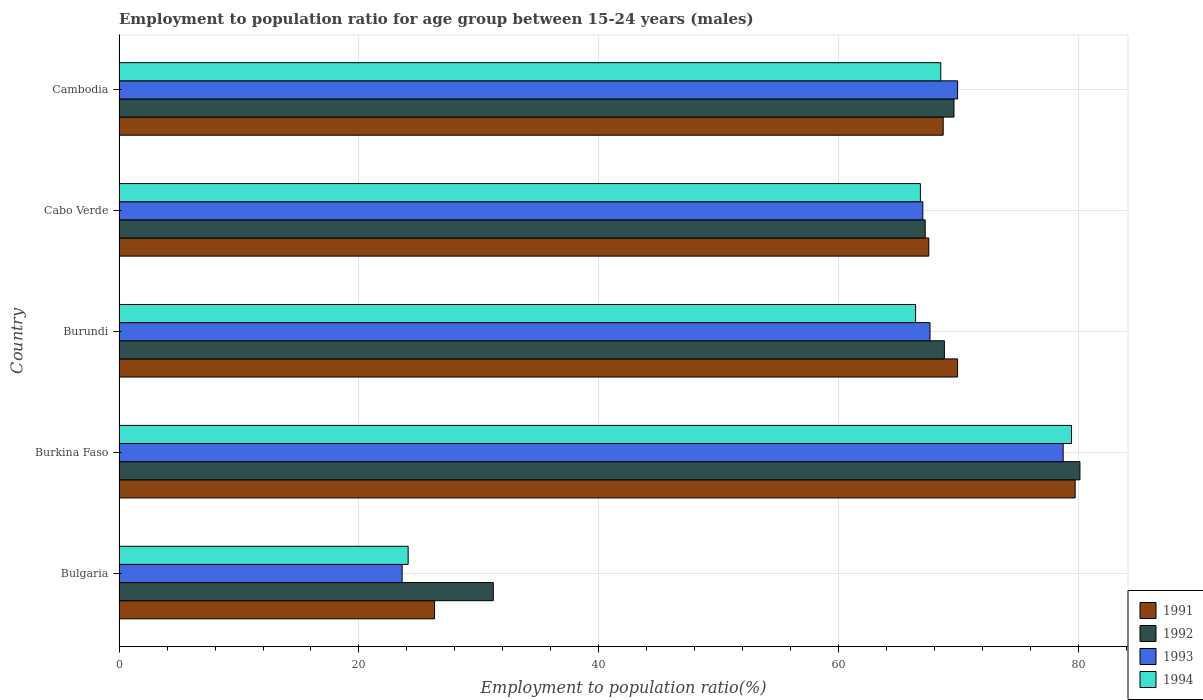How many different coloured bars are there?
Offer a terse response. 4. How many groups of bars are there?
Provide a succinct answer. 5. Are the number of bars on each tick of the Y-axis equal?
Provide a succinct answer. Yes. How many bars are there on the 4th tick from the top?
Keep it short and to the point. 4. How many bars are there on the 1st tick from the bottom?
Offer a terse response. 4. What is the label of the 3rd group of bars from the top?
Keep it short and to the point. Burundi. What is the employment to population ratio in 1992 in Burkina Faso?
Your answer should be compact. 80.1. Across all countries, what is the maximum employment to population ratio in 1993?
Offer a very short reply. 78.7. Across all countries, what is the minimum employment to population ratio in 1993?
Keep it short and to the point. 23.6. In which country was the employment to population ratio in 1994 maximum?
Provide a short and direct response. Burkina Faso. What is the total employment to population ratio in 1992 in the graph?
Provide a short and direct response. 316.9. What is the difference between the employment to population ratio in 1993 in Bulgaria and that in Burundi?
Provide a succinct answer. -44. What is the difference between the employment to population ratio in 1994 in Cambodia and the employment to population ratio in 1991 in Bulgaria?
Offer a very short reply. 42.2. What is the average employment to population ratio in 1991 per country?
Provide a succinct answer. 62.42. What is the difference between the employment to population ratio in 1993 and employment to population ratio in 1994 in Bulgaria?
Keep it short and to the point. -0.5. What is the ratio of the employment to population ratio in 1991 in Bulgaria to that in Burkina Faso?
Keep it short and to the point. 0.33. Is the employment to population ratio in 1991 in Bulgaria less than that in Burundi?
Make the answer very short. Yes. Is the difference between the employment to population ratio in 1993 in Burkina Faso and Cambodia greater than the difference between the employment to population ratio in 1994 in Burkina Faso and Cambodia?
Ensure brevity in your answer.  No. What is the difference between the highest and the lowest employment to population ratio in 1992?
Give a very brief answer. 48.9. Is it the case that in every country, the sum of the employment to population ratio in 1994 and employment to population ratio in 1991 is greater than the sum of employment to population ratio in 1993 and employment to population ratio in 1992?
Offer a terse response. No. Is it the case that in every country, the sum of the employment to population ratio in 1993 and employment to population ratio in 1992 is greater than the employment to population ratio in 1991?
Offer a terse response. Yes. How many bars are there?
Ensure brevity in your answer.  20. Are all the bars in the graph horizontal?
Give a very brief answer. Yes. How many countries are there in the graph?
Offer a very short reply. 5. What is the difference between two consecutive major ticks on the X-axis?
Give a very brief answer. 20. Are the values on the major ticks of X-axis written in scientific E-notation?
Make the answer very short. No. Does the graph contain any zero values?
Offer a terse response. No. Does the graph contain grids?
Keep it short and to the point. Yes. Where does the legend appear in the graph?
Your answer should be very brief. Bottom right. How are the legend labels stacked?
Make the answer very short. Vertical. What is the title of the graph?
Your answer should be very brief. Employment to population ratio for age group between 15-24 years (males). What is the label or title of the Y-axis?
Make the answer very short. Country. What is the Employment to population ratio(%) of 1991 in Bulgaria?
Offer a terse response. 26.3. What is the Employment to population ratio(%) of 1992 in Bulgaria?
Ensure brevity in your answer.  31.2. What is the Employment to population ratio(%) in 1993 in Bulgaria?
Keep it short and to the point. 23.6. What is the Employment to population ratio(%) in 1994 in Bulgaria?
Offer a terse response. 24.1. What is the Employment to population ratio(%) of 1991 in Burkina Faso?
Your answer should be compact. 79.7. What is the Employment to population ratio(%) of 1992 in Burkina Faso?
Your answer should be very brief. 80.1. What is the Employment to population ratio(%) in 1993 in Burkina Faso?
Give a very brief answer. 78.7. What is the Employment to population ratio(%) of 1994 in Burkina Faso?
Provide a short and direct response. 79.4. What is the Employment to population ratio(%) in 1991 in Burundi?
Provide a short and direct response. 69.9. What is the Employment to population ratio(%) of 1992 in Burundi?
Your response must be concise. 68.8. What is the Employment to population ratio(%) in 1993 in Burundi?
Make the answer very short. 67.6. What is the Employment to population ratio(%) of 1994 in Burundi?
Give a very brief answer. 66.4. What is the Employment to population ratio(%) in 1991 in Cabo Verde?
Your answer should be very brief. 67.5. What is the Employment to population ratio(%) in 1992 in Cabo Verde?
Keep it short and to the point. 67.2. What is the Employment to population ratio(%) in 1994 in Cabo Verde?
Give a very brief answer. 66.8. What is the Employment to population ratio(%) in 1991 in Cambodia?
Keep it short and to the point. 68.7. What is the Employment to population ratio(%) of 1992 in Cambodia?
Offer a very short reply. 69.6. What is the Employment to population ratio(%) in 1993 in Cambodia?
Provide a succinct answer. 69.9. What is the Employment to population ratio(%) in 1994 in Cambodia?
Provide a short and direct response. 68.5. Across all countries, what is the maximum Employment to population ratio(%) in 1991?
Make the answer very short. 79.7. Across all countries, what is the maximum Employment to population ratio(%) in 1992?
Offer a very short reply. 80.1. Across all countries, what is the maximum Employment to population ratio(%) in 1993?
Offer a very short reply. 78.7. Across all countries, what is the maximum Employment to population ratio(%) in 1994?
Make the answer very short. 79.4. Across all countries, what is the minimum Employment to population ratio(%) of 1991?
Your answer should be very brief. 26.3. Across all countries, what is the minimum Employment to population ratio(%) in 1992?
Your answer should be very brief. 31.2. Across all countries, what is the minimum Employment to population ratio(%) in 1993?
Ensure brevity in your answer.  23.6. Across all countries, what is the minimum Employment to population ratio(%) of 1994?
Offer a very short reply. 24.1. What is the total Employment to population ratio(%) in 1991 in the graph?
Offer a very short reply. 312.1. What is the total Employment to population ratio(%) of 1992 in the graph?
Your answer should be very brief. 316.9. What is the total Employment to population ratio(%) of 1993 in the graph?
Offer a terse response. 306.8. What is the total Employment to population ratio(%) of 1994 in the graph?
Provide a succinct answer. 305.2. What is the difference between the Employment to population ratio(%) in 1991 in Bulgaria and that in Burkina Faso?
Your answer should be compact. -53.4. What is the difference between the Employment to population ratio(%) of 1992 in Bulgaria and that in Burkina Faso?
Provide a succinct answer. -48.9. What is the difference between the Employment to population ratio(%) in 1993 in Bulgaria and that in Burkina Faso?
Provide a short and direct response. -55.1. What is the difference between the Employment to population ratio(%) of 1994 in Bulgaria and that in Burkina Faso?
Offer a terse response. -55.3. What is the difference between the Employment to population ratio(%) of 1991 in Bulgaria and that in Burundi?
Ensure brevity in your answer.  -43.6. What is the difference between the Employment to population ratio(%) of 1992 in Bulgaria and that in Burundi?
Provide a short and direct response. -37.6. What is the difference between the Employment to population ratio(%) of 1993 in Bulgaria and that in Burundi?
Offer a terse response. -44. What is the difference between the Employment to population ratio(%) of 1994 in Bulgaria and that in Burundi?
Provide a succinct answer. -42.3. What is the difference between the Employment to population ratio(%) of 1991 in Bulgaria and that in Cabo Verde?
Offer a very short reply. -41.2. What is the difference between the Employment to population ratio(%) of 1992 in Bulgaria and that in Cabo Verde?
Provide a succinct answer. -36. What is the difference between the Employment to population ratio(%) of 1993 in Bulgaria and that in Cabo Verde?
Provide a short and direct response. -43.4. What is the difference between the Employment to population ratio(%) of 1994 in Bulgaria and that in Cabo Verde?
Offer a terse response. -42.7. What is the difference between the Employment to population ratio(%) in 1991 in Bulgaria and that in Cambodia?
Offer a terse response. -42.4. What is the difference between the Employment to population ratio(%) of 1992 in Bulgaria and that in Cambodia?
Provide a succinct answer. -38.4. What is the difference between the Employment to population ratio(%) of 1993 in Bulgaria and that in Cambodia?
Offer a very short reply. -46.3. What is the difference between the Employment to population ratio(%) of 1994 in Bulgaria and that in Cambodia?
Provide a succinct answer. -44.4. What is the difference between the Employment to population ratio(%) in 1991 in Burkina Faso and that in Burundi?
Your answer should be compact. 9.8. What is the difference between the Employment to population ratio(%) in 1993 in Burkina Faso and that in Burundi?
Offer a terse response. 11.1. What is the difference between the Employment to population ratio(%) of 1994 in Burkina Faso and that in Burundi?
Your response must be concise. 13. What is the difference between the Employment to population ratio(%) in 1992 in Burkina Faso and that in Cabo Verde?
Your answer should be very brief. 12.9. What is the difference between the Employment to population ratio(%) in 1993 in Burkina Faso and that in Cabo Verde?
Your answer should be very brief. 11.7. What is the difference between the Employment to population ratio(%) in 1992 in Burkina Faso and that in Cambodia?
Ensure brevity in your answer.  10.5. What is the difference between the Employment to population ratio(%) in 1994 in Burkina Faso and that in Cambodia?
Keep it short and to the point. 10.9. What is the difference between the Employment to population ratio(%) in 1991 in Burundi and that in Cabo Verde?
Your answer should be very brief. 2.4. What is the difference between the Employment to population ratio(%) of 1992 in Burundi and that in Cabo Verde?
Give a very brief answer. 1.6. What is the difference between the Employment to population ratio(%) of 1993 in Burundi and that in Cabo Verde?
Provide a succinct answer. 0.6. What is the difference between the Employment to population ratio(%) in 1994 in Burundi and that in Cabo Verde?
Offer a terse response. -0.4. What is the difference between the Employment to population ratio(%) of 1991 in Burundi and that in Cambodia?
Keep it short and to the point. 1.2. What is the difference between the Employment to population ratio(%) in 1994 in Burundi and that in Cambodia?
Your response must be concise. -2.1. What is the difference between the Employment to population ratio(%) of 1991 in Cabo Verde and that in Cambodia?
Provide a succinct answer. -1.2. What is the difference between the Employment to population ratio(%) of 1991 in Bulgaria and the Employment to population ratio(%) of 1992 in Burkina Faso?
Make the answer very short. -53.8. What is the difference between the Employment to population ratio(%) of 1991 in Bulgaria and the Employment to population ratio(%) of 1993 in Burkina Faso?
Keep it short and to the point. -52.4. What is the difference between the Employment to population ratio(%) in 1991 in Bulgaria and the Employment to population ratio(%) in 1994 in Burkina Faso?
Provide a short and direct response. -53.1. What is the difference between the Employment to population ratio(%) of 1992 in Bulgaria and the Employment to population ratio(%) of 1993 in Burkina Faso?
Give a very brief answer. -47.5. What is the difference between the Employment to population ratio(%) in 1992 in Bulgaria and the Employment to population ratio(%) in 1994 in Burkina Faso?
Ensure brevity in your answer.  -48.2. What is the difference between the Employment to population ratio(%) in 1993 in Bulgaria and the Employment to population ratio(%) in 1994 in Burkina Faso?
Ensure brevity in your answer.  -55.8. What is the difference between the Employment to population ratio(%) of 1991 in Bulgaria and the Employment to population ratio(%) of 1992 in Burundi?
Keep it short and to the point. -42.5. What is the difference between the Employment to population ratio(%) in 1991 in Bulgaria and the Employment to population ratio(%) in 1993 in Burundi?
Offer a very short reply. -41.3. What is the difference between the Employment to population ratio(%) in 1991 in Bulgaria and the Employment to population ratio(%) in 1994 in Burundi?
Make the answer very short. -40.1. What is the difference between the Employment to population ratio(%) in 1992 in Bulgaria and the Employment to population ratio(%) in 1993 in Burundi?
Your answer should be very brief. -36.4. What is the difference between the Employment to population ratio(%) in 1992 in Bulgaria and the Employment to population ratio(%) in 1994 in Burundi?
Keep it short and to the point. -35.2. What is the difference between the Employment to population ratio(%) of 1993 in Bulgaria and the Employment to population ratio(%) of 1994 in Burundi?
Your answer should be very brief. -42.8. What is the difference between the Employment to population ratio(%) of 1991 in Bulgaria and the Employment to population ratio(%) of 1992 in Cabo Verde?
Your response must be concise. -40.9. What is the difference between the Employment to population ratio(%) in 1991 in Bulgaria and the Employment to population ratio(%) in 1993 in Cabo Verde?
Ensure brevity in your answer.  -40.7. What is the difference between the Employment to population ratio(%) in 1991 in Bulgaria and the Employment to population ratio(%) in 1994 in Cabo Verde?
Your answer should be compact. -40.5. What is the difference between the Employment to population ratio(%) of 1992 in Bulgaria and the Employment to population ratio(%) of 1993 in Cabo Verde?
Provide a succinct answer. -35.8. What is the difference between the Employment to population ratio(%) in 1992 in Bulgaria and the Employment to population ratio(%) in 1994 in Cabo Verde?
Offer a terse response. -35.6. What is the difference between the Employment to population ratio(%) in 1993 in Bulgaria and the Employment to population ratio(%) in 1994 in Cabo Verde?
Your answer should be very brief. -43.2. What is the difference between the Employment to population ratio(%) of 1991 in Bulgaria and the Employment to population ratio(%) of 1992 in Cambodia?
Make the answer very short. -43.3. What is the difference between the Employment to population ratio(%) of 1991 in Bulgaria and the Employment to population ratio(%) of 1993 in Cambodia?
Give a very brief answer. -43.6. What is the difference between the Employment to population ratio(%) in 1991 in Bulgaria and the Employment to population ratio(%) in 1994 in Cambodia?
Make the answer very short. -42.2. What is the difference between the Employment to population ratio(%) in 1992 in Bulgaria and the Employment to population ratio(%) in 1993 in Cambodia?
Provide a short and direct response. -38.7. What is the difference between the Employment to population ratio(%) of 1992 in Bulgaria and the Employment to population ratio(%) of 1994 in Cambodia?
Make the answer very short. -37.3. What is the difference between the Employment to population ratio(%) in 1993 in Bulgaria and the Employment to population ratio(%) in 1994 in Cambodia?
Make the answer very short. -44.9. What is the difference between the Employment to population ratio(%) of 1991 in Burkina Faso and the Employment to population ratio(%) of 1992 in Burundi?
Keep it short and to the point. 10.9. What is the difference between the Employment to population ratio(%) of 1991 in Burkina Faso and the Employment to population ratio(%) of 1994 in Burundi?
Your response must be concise. 13.3. What is the difference between the Employment to population ratio(%) in 1992 in Burkina Faso and the Employment to population ratio(%) in 1994 in Burundi?
Your answer should be very brief. 13.7. What is the difference between the Employment to population ratio(%) in 1991 in Burkina Faso and the Employment to population ratio(%) in 1992 in Cabo Verde?
Ensure brevity in your answer.  12.5. What is the difference between the Employment to population ratio(%) in 1991 in Burkina Faso and the Employment to population ratio(%) in 1993 in Cabo Verde?
Provide a short and direct response. 12.7. What is the difference between the Employment to population ratio(%) of 1992 in Burkina Faso and the Employment to population ratio(%) of 1994 in Cabo Verde?
Offer a terse response. 13.3. What is the difference between the Employment to population ratio(%) of 1991 in Burkina Faso and the Employment to population ratio(%) of 1993 in Cambodia?
Provide a short and direct response. 9.8. What is the difference between the Employment to population ratio(%) in 1992 in Burkina Faso and the Employment to population ratio(%) in 1994 in Cambodia?
Give a very brief answer. 11.6. What is the difference between the Employment to population ratio(%) in 1991 in Burundi and the Employment to population ratio(%) in 1992 in Cabo Verde?
Your answer should be very brief. 2.7. What is the difference between the Employment to population ratio(%) in 1991 in Burundi and the Employment to population ratio(%) in 1993 in Cabo Verde?
Your answer should be very brief. 2.9. What is the difference between the Employment to population ratio(%) of 1991 in Burundi and the Employment to population ratio(%) of 1994 in Cabo Verde?
Provide a short and direct response. 3.1. What is the difference between the Employment to population ratio(%) in 1992 in Burundi and the Employment to population ratio(%) in 1993 in Cabo Verde?
Provide a short and direct response. 1.8. What is the difference between the Employment to population ratio(%) in 1991 in Burundi and the Employment to population ratio(%) in 1993 in Cambodia?
Make the answer very short. 0. What is the difference between the Employment to population ratio(%) of 1991 in Burundi and the Employment to population ratio(%) of 1994 in Cambodia?
Your answer should be very brief. 1.4. What is the difference between the Employment to population ratio(%) of 1991 in Cabo Verde and the Employment to population ratio(%) of 1992 in Cambodia?
Provide a succinct answer. -2.1. What is the difference between the Employment to population ratio(%) of 1991 in Cabo Verde and the Employment to population ratio(%) of 1993 in Cambodia?
Make the answer very short. -2.4. What is the difference between the Employment to population ratio(%) of 1991 in Cabo Verde and the Employment to population ratio(%) of 1994 in Cambodia?
Provide a short and direct response. -1. What is the difference between the Employment to population ratio(%) of 1992 in Cabo Verde and the Employment to population ratio(%) of 1993 in Cambodia?
Provide a short and direct response. -2.7. What is the difference between the Employment to population ratio(%) of 1993 in Cabo Verde and the Employment to population ratio(%) of 1994 in Cambodia?
Make the answer very short. -1.5. What is the average Employment to population ratio(%) of 1991 per country?
Make the answer very short. 62.42. What is the average Employment to population ratio(%) of 1992 per country?
Your answer should be very brief. 63.38. What is the average Employment to population ratio(%) in 1993 per country?
Your response must be concise. 61.36. What is the average Employment to population ratio(%) of 1994 per country?
Keep it short and to the point. 61.04. What is the difference between the Employment to population ratio(%) in 1991 and Employment to population ratio(%) in 1992 in Bulgaria?
Provide a short and direct response. -4.9. What is the difference between the Employment to population ratio(%) of 1991 and Employment to population ratio(%) of 1993 in Bulgaria?
Your answer should be compact. 2.7. What is the difference between the Employment to population ratio(%) in 1992 and Employment to population ratio(%) in 1994 in Bulgaria?
Keep it short and to the point. 7.1. What is the difference between the Employment to population ratio(%) of 1991 and Employment to population ratio(%) of 1994 in Burkina Faso?
Make the answer very short. 0.3. What is the difference between the Employment to population ratio(%) of 1992 and Employment to population ratio(%) of 1993 in Burkina Faso?
Give a very brief answer. 1.4. What is the difference between the Employment to population ratio(%) of 1991 and Employment to population ratio(%) of 1992 in Burundi?
Provide a succinct answer. 1.1. What is the difference between the Employment to population ratio(%) of 1992 and Employment to population ratio(%) of 1994 in Burundi?
Offer a very short reply. 2.4. What is the difference between the Employment to population ratio(%) in 1993 and Employment to population ratio(%) in 1994 in Burundi?
Your answer should be compact. 1.2. What is the difference between the Employment to population ratio(%) of 1991 and Employment to population ratio(%) of 1992 in Cabo Verde?
Provide a short and direct response. 0.3. What is the difference between the Employment to population ratio(%) of 1991 and Employment to population ratio(%) of 1994 in Cabo Verde?
Make the answer very short. 0.7. What is the difference between the Employment to population ratio(%) of 1992 and Employment to population ratio(%) of 1993 in Cabo Verde?
Keep it short and to the point. 0.2. What is the difference between the Employment to population ratio(%) in 1992 and Employment to population ratio(%) in 1994 in Cabo Verde?
Your answer should be very brief. 0.4. What is the difference between the Employment to population ratio(%) of 1991 and Employment to population ratio(%) of 1992 in Cambodia?
Offer a terse response. -0.9. What is the difference between the Employment to population ratio(%) in 1992 and Employment to population ratio(%) in 1993 in Cambodia?
Your answer should be compact. -0.3. What is the difference between the Employment to population ratio(%) of 1992 and Employment to population ratio(%) of 1994 in Cambodia?
Give a very brief answer. 1.1. What is the ratio of the Employment to population ratio(%) in 1991 in Bulgaria to that in Burkina Faso?
Your response must be concise. 0.33. What is the ratio of the Employment to population ratio(%) in 1992 in Bulgaria to that in Burkina Faso?
Your answer should be compact. 0.39. What is the ratio of the Employment to population ratio(%) of 1993 in Bulgaria to that in Burkina Faso?
Your answer should be compact. 0.3. What is the ratio of the Employment to population ratio(%) of 1994 in Bulgaria to that in Burkina Faso?
Make the answer very short. 0.3. What is the ratio of the Employment to population ratio(%) of 1991 in Bulgaria to that in Burundi?
Your response must be concise. 0.38. What is the ratio of the Employment to population ratio(%) in 1992 in Bulgaria to that in Burundi?
Keep it short and to the point. 0.45. What is the ratio of the Employment to population ratio(%) in 1993 in Bulgaria to that in Burundi?
Provide a succinct answer. 0.35. What is the ratio of the Employment to population ratio(%) of 1994 in Bulgaria to that in Burundi?
Keep it short and to the point. 0.36. What is the ratio of the Employment to population ratio(%) of 1991 in Bulgaria to that in Cabo Verde?
Make the answer very short. 0.39. What is the ratio of the Employment to population ratio(%) of 1992 in Bulgaria to that in Cabo Verde?
Provide a short and direct response. 0.46. What is the ratio of the Employment to population ratio(%) of 1993 in Bulgaria to that in Cabo Verde?
Ensure brevity in your answer.  0.35. What is the ratio of the Employment to population ratio(%) in 1994 in Bulgaria to that in Cabo Verde?
Provide a succinct answer. 0.36. What is the ratio of the Employment to population ratio(%) in 1991 in Bulgaria to that in Cambodia?
Offer a terse response. 0.38. What is the ratio of the Employment to population ratio(%) in 1992 in Bulgaria to that in Cambodia?
Make the answer very short. 0.45. What is the ratio of the Employment to population ratio(%) in 1993 in Bulgaria to that in Cambodia?
Give a very brief answer. 0.34. What is the ratio of the Employment to population ratio(%) of 1994 in Bulgaria to that in Cambodia?
Your answer should be very brief. 0.35. What is the ratio of the Employment to population ratio(%) of 1991 in Burkina Faso to that in Burundi?
Offer a very short reply. 1.14. What is the ratio of the Employment to population ratio(%) in 1992 in Burkina Faso to that in Burundi?
Your answer should be compact. 1.16. What is the ratio of the Employment to population ratio(%) of 1993 in Burkina Faso to that in Burundi?
Make the answer very short. 1.16. What is the ratio of the Employment to population ratio(%) in 1994 in Burkina Faso to that in Burundi?
Ensure brevity in your answer.  1.2. What is the ratio of the Employment to population ratio(%) in 1991 in Burkina Faso to that in Cabo Verde?
Provide a succinct answer. 1.18. What is the ratio of the Employment to population ratio(%) in 1992 in Burkina Faso to that in Cabo Verde?
Your response must be concise. 1.19. What is the ratio of the Employment to population ratio(%) in 1993 in Burkina Faso to that in Cabo Verde?
Make the answer very short. 1.17. What is the ratio of the Employment to population ratio(%) in 1994 in Burkina Faso to that in Cabo Verde?
Offer a very short reply. 1.19. What is the ratio of the Employment to population ratio(%) of 1991 in Burkina Faso to that in Cambodia?
Give a very brief answer. 1.16. What is the ratio of the Employment to population ratio(%) in 1992 in Burkina Faso to that in Cambodia?
Your answer should be very brief. 1.15. What is the ratio of the Employment to population ratio(%) of 1993 in Burkina Faso to that in Cambodia?
Your response must be concise. 1.13. What is the ratio of the Employment to population ratio(%) in 1994 in Burkina Faso to that in Cambodia?
Make the answer very short. 1.16. What is the ratio of the Employment to population ratio(%) of 1991 in Burundi to that in Cabo Verde?
Offer a terse response. 1.04. What is the ratio of the Employment to population ratio(%) in 1992 in Burundi to that in Cabo Verde?
Your answer should be very brief. 1.02. What is the ratio of the Employment to population ratio(%) in 1993 in Burundi to that in Cabo Verde?
Your answer should be very brief. 1.01. What is the ratio of the Employment to population ratio(%) in 1991 in Burundi to that in Cambodia?
Offer a terse response. 1.02. What is the ratio of the Employment to population ratio(%) in 1992 in Burundi to that in Cambodia?
Your answer should be very brief. 0.99. What is the ratio of the Employment to population ratio(%) in 1993 in Burundi to that in Cambodia?
Provide a short and direct response. 0.97. What is the ratio of the Employment to population ratio(%) in 1994 in Burundi to that in Cambodia?
Offer a terse response. 0.97. What is the ratio of the Employment to population ratio(%) in 1991 in Cabo Verde to that in Cambodia?
Your answer should be compact. 0.98. What is the ratio of the Employment to population ratio(%) in 1992 in Cabo Verde to that in Cambodia?
Give a very brief answer. 0.97. What is the ratio of the Employment to population ratio(%) in 1993 in Cabo Verde to that in Cambodia?
Provide a short and direct response. 0.96. What is the ratio of the Employment to population ratio(%) in 1994 in Cabo Verde to that in Cambodia?
Your answer should be compact. 0.98. What is the difference between the highest and the second highest Employment to population ratio(%) in 1992?
Provide a short and direct response. 10.5. What is the difference between the highest and the second highest Employment to population ratio(%) of 1994?
Your answer should be compact. 10.9. What is the difference between the highest and the lowest Employment to population ratio(%) of 1991?
Give a very brief answer. 53.4. What is the difference between the highest and the lowest Employment to population ratio(%) of 1992?
Make the answer very short. 48.9. What is the difference between the highest and the lowest Employment to population ratio(%) in 1993?
Your answer should be compact. 55.1. What is the difference between the highest and the lowest Employment to population ratio(%) of 1994?
Provide a succinct answer. 55.3. 